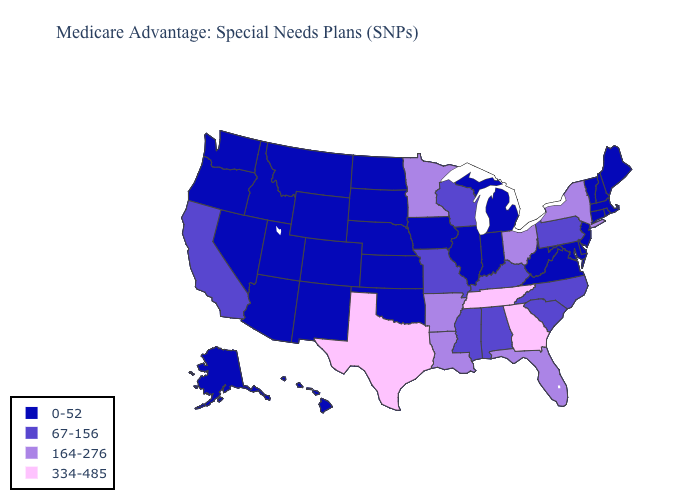Name the states that have a value in the range 334-485?
Short answer required. Georgia, Tennessee, Texas. What is the value of Nebraska?
Quick response, please. 0-52. Name the states that have a value in the range 0-52?
Short answer required. Alaska, Arizona, Colorado, Connecticut, Delaware, Hawaii, Iowa, Idaho, Illinois, Indiana, Kansas, Massachusetts, Maryland, Maine, Michigan, Montana, North Dakota, Nebraska, New Hampshire, New Jersey, New Mexico, Nevada, Oklahoma, Oregon, Rhode Island, South Dakota, Utah, Virginia, Vermont, Washington, West Virginia, Wyoming. Does North Dakota have the highest value in the MidWest?
Write a very short answer. No. Name the states that have a value in the range 164-276?
Be succinct. Arkansas, Florida, Louisiana, Minnesota, New York, Ohio. Does Washington have a lower value than Texas?
Give a very brief answer. Yes. Does New Hampshire have the lowest value in the Northeast?
Give a very brief answer. Yes. Which states hav the highest value in the South?
Keep it brief. Georgia, Tennessee, Texas. Which states have the highest value in the USA?
Write a very short answer. Georgia, Tennessee, Texas. Among the states that border Indiana , does Ohio have the highest value?
Short answer required. Yes. What is the value of Vermont?
Quick response, please. 0-52. Does New Mexico have the same value as Connecticut?
Answer briefly. Yes. Which states have the lowest value in the USA?
Quick response, please. Alaska, Arizona, Colorado, Connecticut, Delaware, Hawaii, Iowa, Idaho, Illinois, Indiana, Kansas, Massachusetts, Maryland, Maine, Michigan, Montana, North Dakota, Nebraska, New Hampshire, New Jersey, New Mexico, Nevada, Oklahoma, Oregon, Rhode Island, South Dakota, Utah, Virginia, Vermont, Washington, West Virginia, Wyoming. 